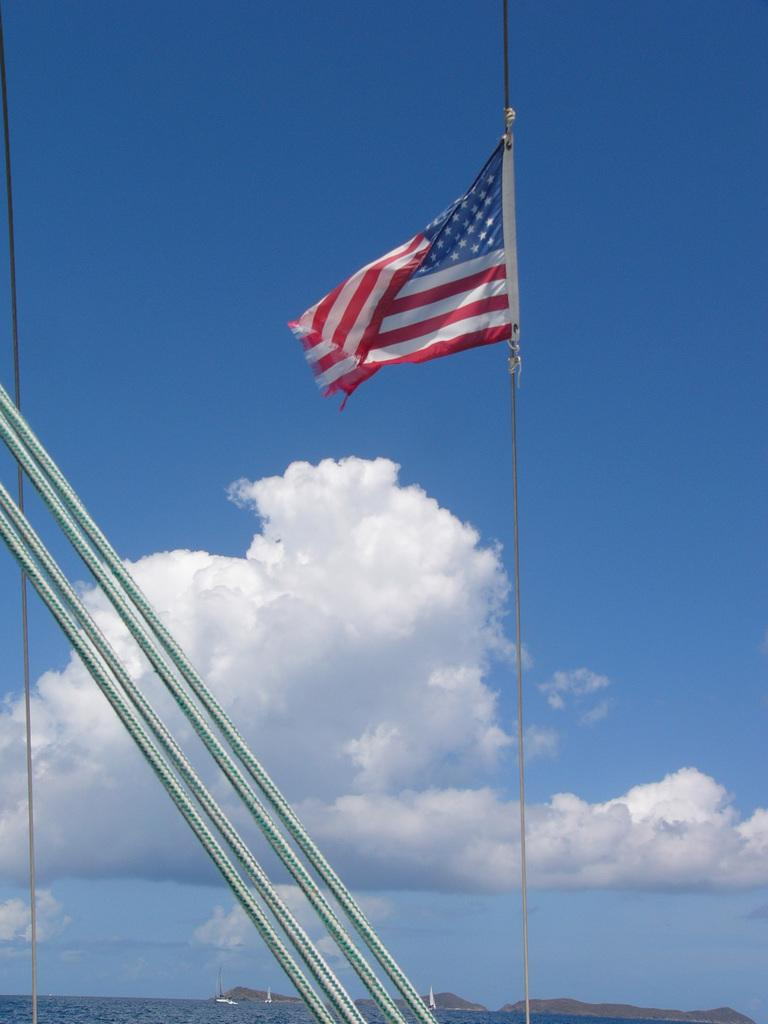What objects are present in the image that are used for support or attachment? There are poles and ropes in the image that are used for support or attachment. What is attached to the poles and ropes in the image? There is a flag attached to the poles and ropes in the image. What can be seen at the bottom of the image? There is water visible at the bottom of the image. What is visible in the sky at the top of the image? There are clouds in the sky at the top of the image. How long does it take for the office to join the clouds in the image? There is no office present in the image, so it is not possible to determine how long it would take for it to join the clouds. 